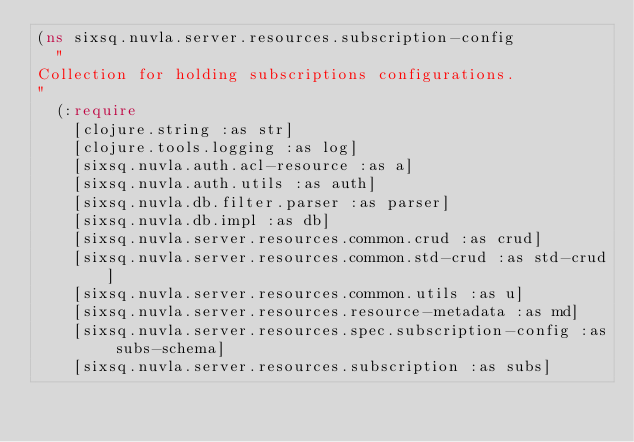Convert code to text. <code><loc_0><loc_0><loc_500><loc_500><_Clojure_>(ns sixsq.nuvla.server.resources.subscription-config
  "
Collection for holding subscriptions configurations.
"
  (:require
    [clojure.string :as str]
    [clojure.tools.logging :as log]
    [sixsq.nuvla.auth.acl-resource :as a]
    [sixsq.nuvla.auth.utils :as auth]
    [sixsq.nuvla.db.filter.parser :as parser]
    [sixsq.nuvla.db.impl :as db]
    [sixsq.nuvla.server.resources.common.crud :as crud]
    [sixsq.nuvla.server.resources.common.std-crud :as std-crud]
    [sixsq.nuvla.server.resources.common.utils :as u]
    [sixsq.nuvla.server.resources.resource-metadata :as md]
    [sixsq.nuvla.server.resources.spec.subscription-config :as subs-schema]
    [sixsq.nuvla.server.resources.subscription :as subs]</code> 